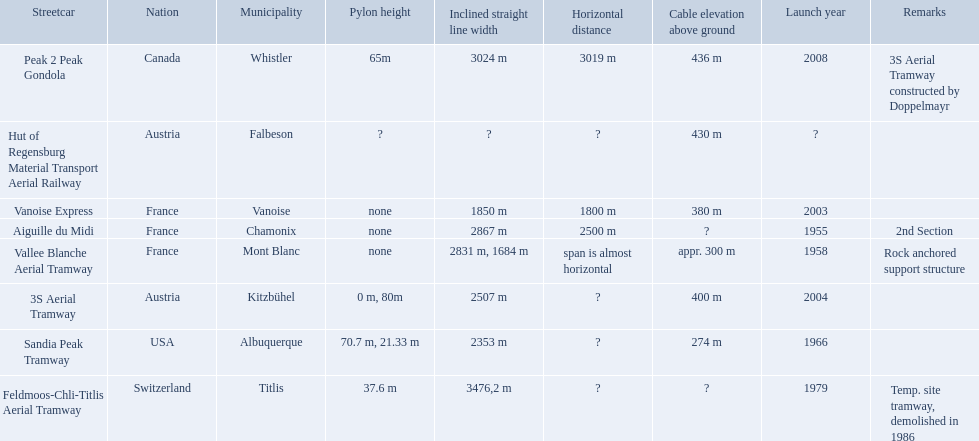What are all of the tramways? Peak 2 Peak Gondola, Hut of Regensburg Material Transport Aerial Railway, Vanoise Express, Aiguille du Midi, Vallee Blanche Aerial Tramway, 3S Aerial Tramway, Sandia Peak Tramway, Feldmoos-Chli-Titlis Aerial Tramway. When were they inaugurated? 2008, ?, 2003, 1955, 1958, 2004, 1966, 1979. Now, between 3s aerial tramway and aiguille du midi, which was inaugurated first? Aiguille du Midi. When was the aiguille du midi tramway inaugurated? 1955. When was the 3s aerial tramway inaugurated? 2004. Which one was inaugurated first? Aiguille du Midi. 